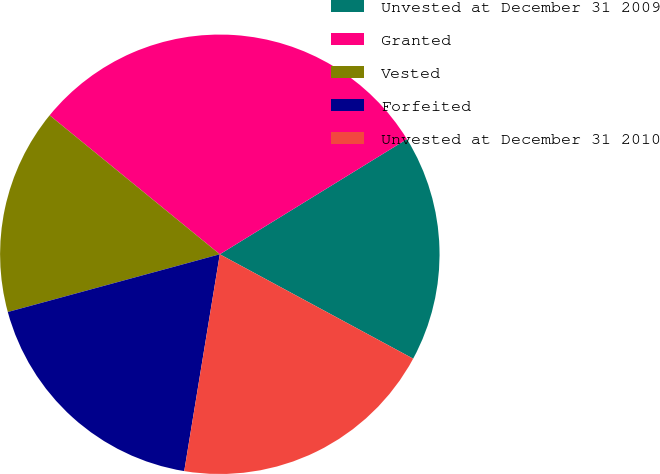Convert chart to OTSL. <chart><loc_0><loc_0><loc_500><loc_500><pie_chart><fcel>Unvested at December 31 2009<fcel>Granted<fcel>Vested<fcel>Forfeited<fcel>Unvested at December 31 2010<nl><fcel>16.66%<fcel>30.32%<fcel>15.13%<fcel>18.18%<fcel>19.71%<nl></chart> 